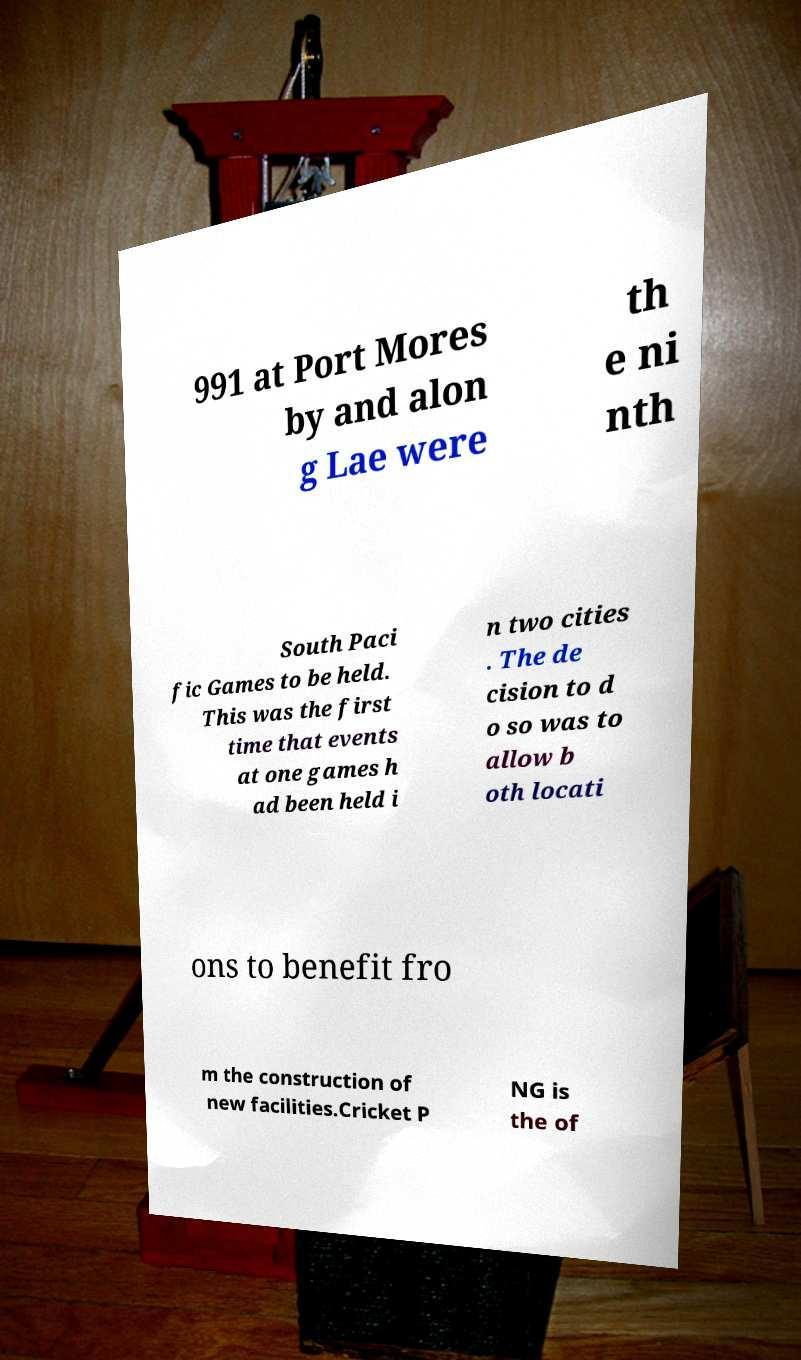Could you extract and type out the text from this image? 991 at Port Mores by and alon g Lae were th e ni nth South Paci fic Games to be held. This was the first time that events at one games h ad been held i n two cities . The de cision to d o so was to allow b oth locati ons to benefit fro m the construction of new facilities.Cricket P NG is the of 